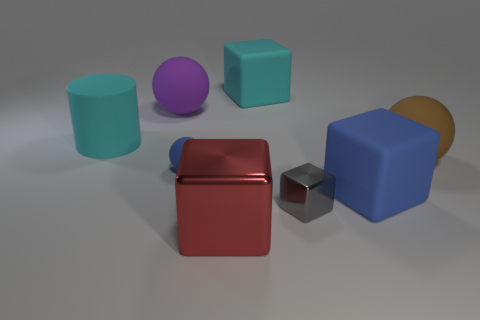Subtract all red metal blocks. How many blocks are left? 3 Subtract all red cubes. How many cubes are left? 3 Add 2 big cyan cylinders. How many objects exist? 10 Subtract 1 balls. How many balls are left? 2 Subtract all green cubes. Subtract all yellow spheres. How many cubes are left? 4 Add 3 blue matte objects. How many blue matte objects are left? 5 Add 6 small shiny things. How many small shiny things exist? 7 Subtract 1 blue balls. How many objects are left? 7 Subtract all cylinders. How many objects are left? 7 Subtract all large rubber cylinders. Subtract all red shiny cubes. How many objects are left? 6 